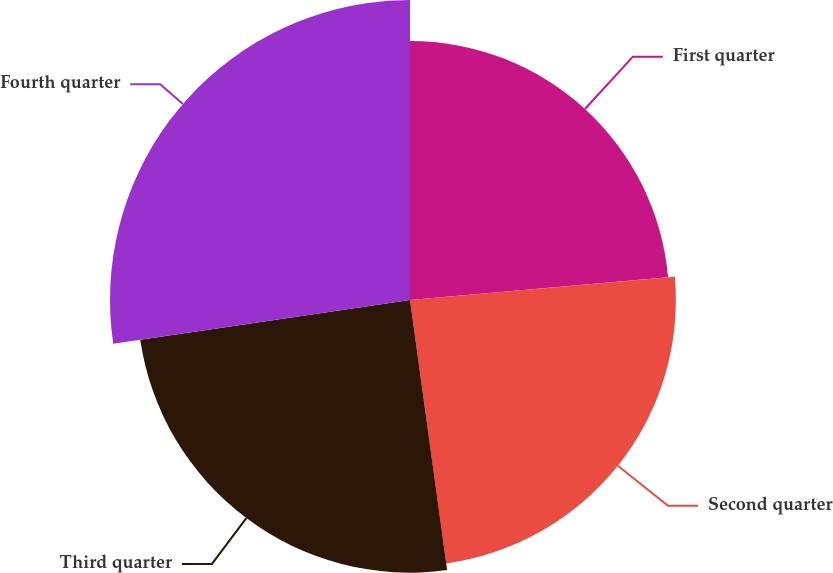<chart> <loc_0><loc_0><loc_500><loc_500><pie_chart><fcel>First quarter<fcel>Second quarter<fcel>Third quarter<fcel>Fourth quarter<nl><fcel>23.6%<fcel>24.22%<fcel>24.84%<fcel>27.33%<nl></chart> 